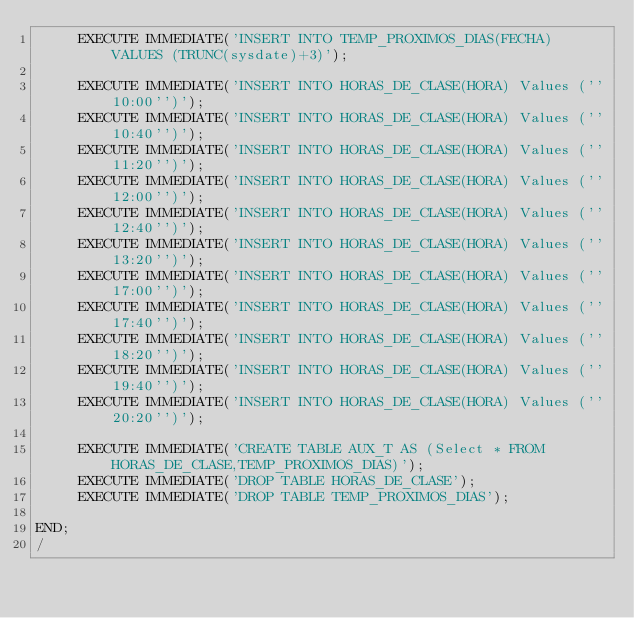Convert code to text. <code><loc_0><loc_0><loc_500><loc_500><_SQL_>     EXECUTE IMMEDIATE('INSERT INTO TEMP_PROXIMOS_DIAS(FECHA) VALUES (TRUNC(sysdate)+3)');
    
     EXECUTE IMMEDIATE('INSERT INTO HORAS_DE_CLASE(HORA) Values (''10:00'')');
     EXECUTE IMMEDIATE('INSERT INTO HORAS_DE_CLASE(HORA) Values (''10:40'')');
     EXECUTE IMMEDIATE('INSERT INTO HORAS_DE_CLASE(HORA) Values (''11:20'')');
     EXECUTE IMMEDIATE('INSERT INTO HORAS_DE_CLASE(HORA) Values (''12:00'')');
     EXECUTE IMMEDIATE('INSERT INTO HORAS_DE_CLASE(HORA) Values (''12:40'')');
     EXECUTE IMMEDIATE('INSERT INTO HORAS_DE_CLASE(HORA) Values (''13:20'')');
     EXECUTE IMMEDIATE('INSERT INTO HORAS_DE_CLASE(HORA) Values (''17:00'')');
     EXECUTE IMMEDIATE('INSERT INTO HORAS_DE_CLASE(HORA) Values (''17:40'')');
     EXECUTE IMMEDIATE('INSERT INTO HORAS_DE_CLASE(HORA) Values (''18:20'')');
     EXECUTE IMMEDIATE('INSERT INTO HORAS_DE_CLASE(HORA) Values (''19:40'')');
     EXECUTE IMMEDIATE('INSERT INTO HORAS_DE_CLASE(HORA) Values (''20:20'')');
    
     EXECUTE IMMEDIATE('CREATE TABLE AUX_T AS (Select * FROM HORAS_DE_CLASE,TEMP_PROXIMOS_DIAS)');
     EXECUTE IMMEDIATE('DROP TABLE HORAS_DE_CLASE');
     EXECUTE IMMEDIATE('DROP TABLE TEMP_PROXIMOS_DIAS');
    
END;
/</code> 